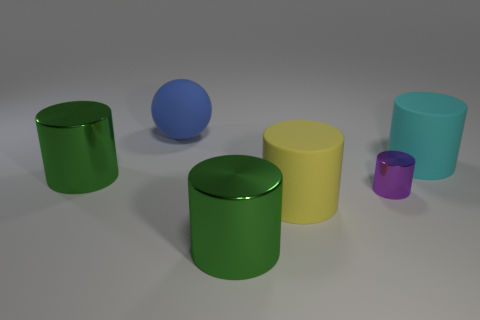Subtract all yellow cylinders. How many cylinders are left? 4 Subtract 2 cylinders. How many cylinders are left? 3 Subtract all purple cylinders. How many cylinders are left? 4 Add 2 green objects. How many objects exist? 8 Subtract all cylinders. How many objects are left? 1 Subtract all tiny green balls. Subtract all big cyan things. How many objects are left? 5 Add 1 metal cylinders. How many metal cylinders are left? 4 Add 2 cyan objects. How many cyan objects exist? 3 Subtract 0 brown spheres. How many objects are left? 6 Subtract all gray cylinders. Subtract all purple spheres. How many cylinders are left? 5 